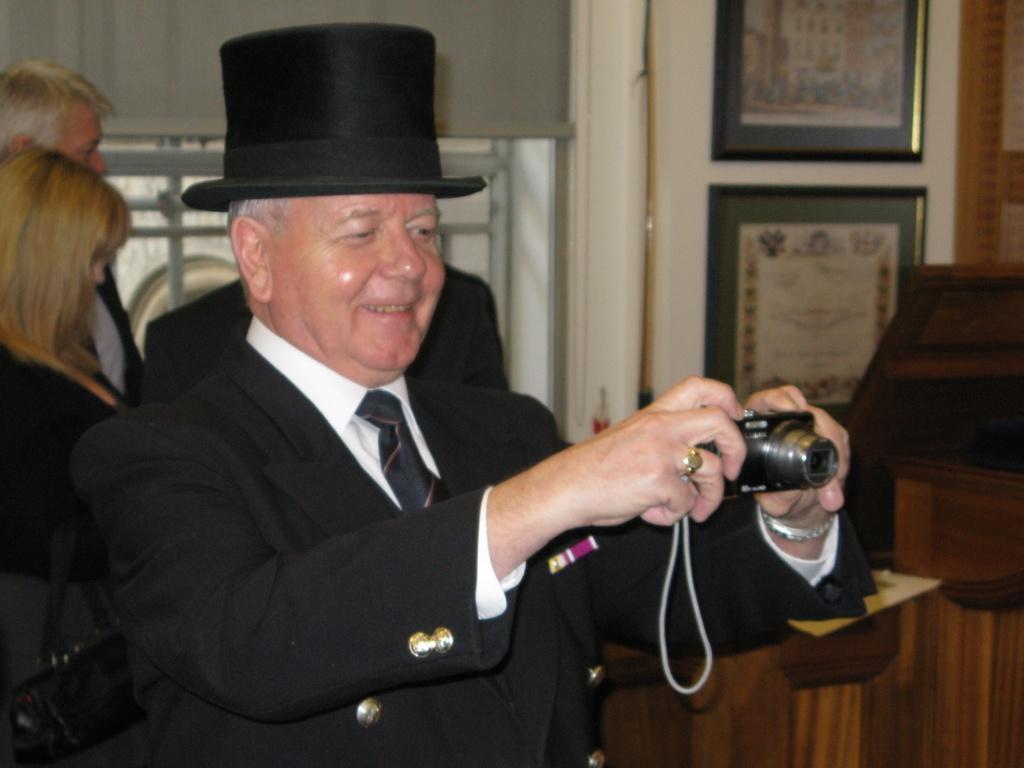In one or two sentences, can you explain what this image depicts? This is a picture taken in a room, the man in black blazer with a black hat holding a camera. Background of this man there are the other people standing on the floor and a wall on the wall there are the frames. 